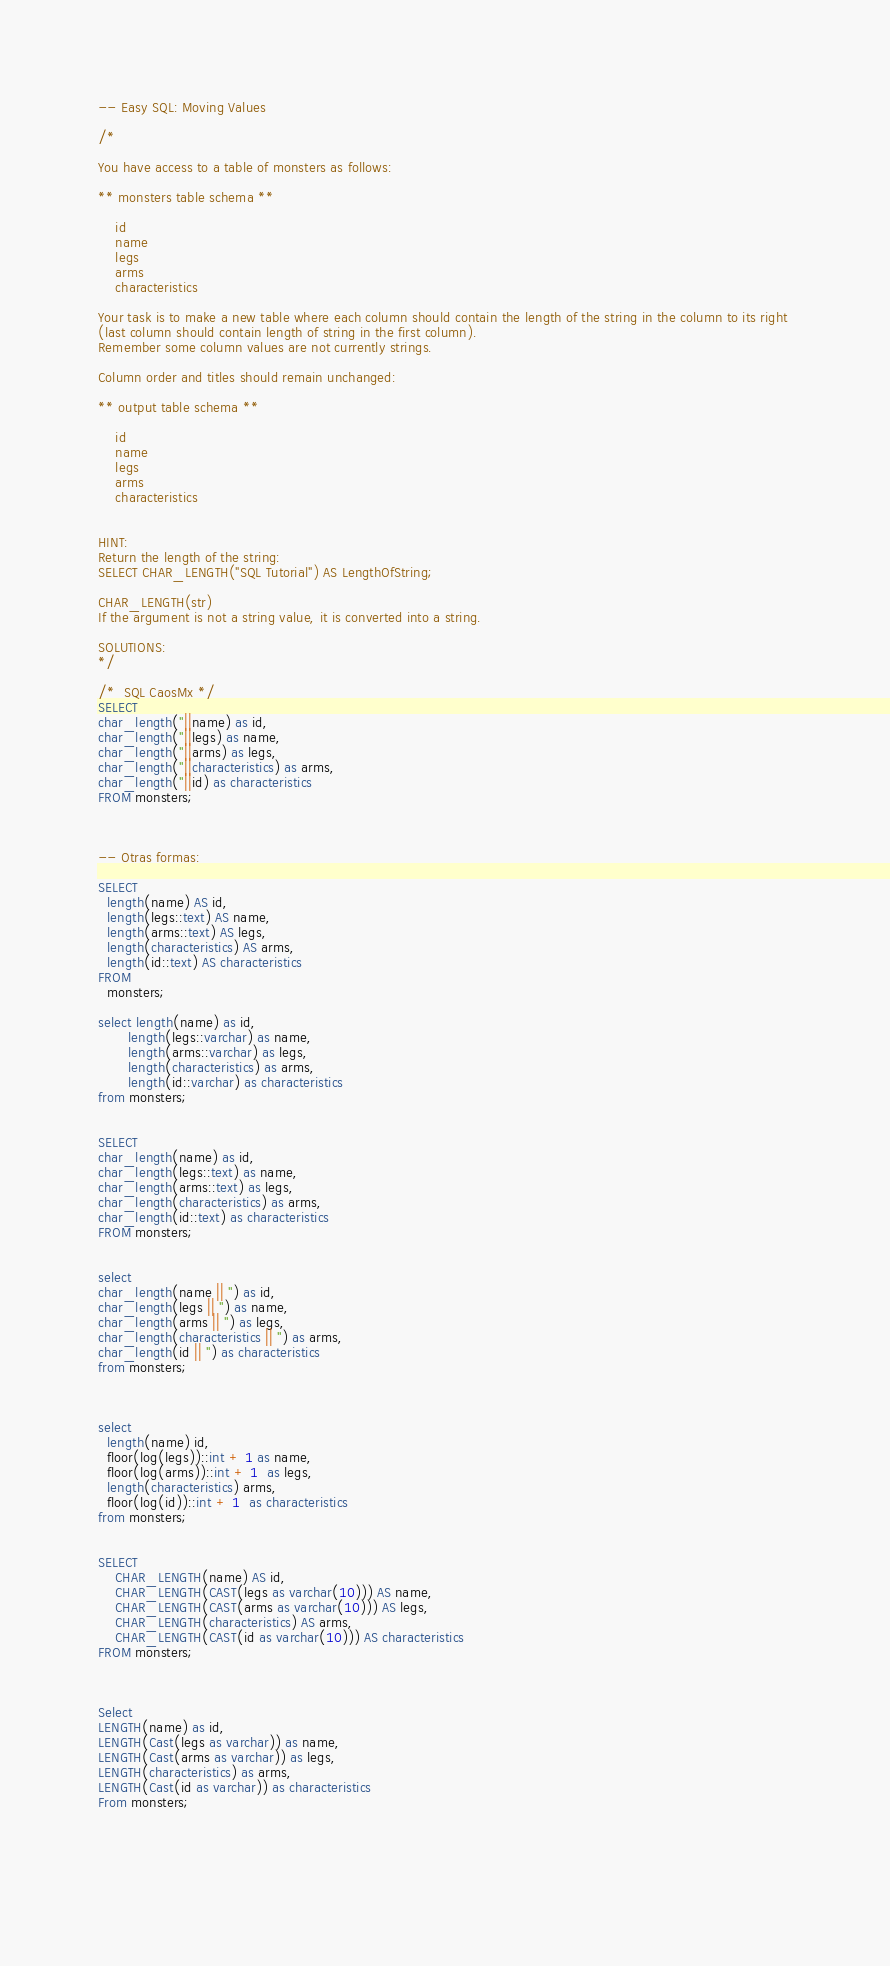Convert code to text. <code><loc_0><loc_0><loc_500><loc_500><_SQL_>-- Easy SQL: Moving Values

/*

You have access to a table of monsters as follows:

** monsters table schema **

    id
    name
    legs
    arms
    characteristics

Your task is to make a new table where each column should contain the length of the string in the column to its right 
(last column should contain length of string in the first column). 
Remember some column values are not currently strings. 

Column order and titles should remain unchanged:

** output table schema **

    id
    name
    legs
    arms
    characteristics


HINT:
Return the length of the string:
SELECT CHAR_LENGTH("SQL Tutorial") AS LengthOfString; 

CHAR_LENGTH(str)
If the argument is not a string value, it is converted into a string.

SOLUTIONS:
*/

/*  SQL CaosMx */
SELECT 
char_length(''||name) as id,
char_length(''||legs) as name,
char_length(''||arms) as legs,
char_length(''||characteristics) as arms,
char_length(''||id) as characteristics
FROM monsters;



-- Otras formas:

SELECT 
  length(name) AS id,
  length(legs::text) AS name,
  length(arms::text) AS legs,
  length(characteristics) AS arms,
  length(id::text) AS characteristics
FROM
  monsters;
  
select length(name) as id, 
       length(legs::varchar) as name, 
       length(arms::varchar) as legs, 
       length(characteristics) as arms, 
       length(id::varchar) as characteristics 
from monsters;


SELECT 
char_length(name) as id,
char_length(legs::text) as name,
char_length(arms::text) as legs,
char_length(characteristics) as arms,
char_length(id::text) as characteristics
FROM monsters;


select 
char_length(name || '') as id, 
char_length(legs || '') as name,
char_length(arms || '') as legs,
char_length(characteristics || '') as arms,
char_length(id || '') as characteristics
from monsters;



select 
  length(name) id,
  floor(log(legs))::int + 1 as name,
  floor(log(arms))::int + 1  as legs,
  length(characteristics) arms,
  floor(log(id))::int + 1  as characteristics
from monsters;


SELECT
    CHAR_LENGTH(name) AS id,
    CHAR_LENGTH(CAST(legs as varchar(10))) AS name, 
    CHAR_LENGTH(CAST(arms as varchar(10))) AS legs, 
    CHAR_LENGTH(characteristics) AS arms, 
    CHAR_LENGTH(CAST(id as varchar(10))) AS characteristics
FROM monsters;



Select 
LENGTH(name) as id,
LENGTH(Cast(legs as varchar)) as name,
LENGTH(Cast(arms as varchar)) as legs,
LENGTH(characteristics) as arms,
LENGTH(Cast(id as varchar)) as characteristics
From monsters;



  

</code> 